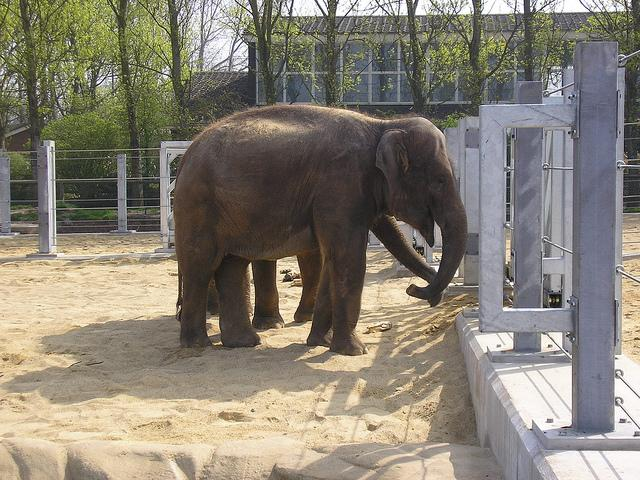What are the elephants standing in?

Choices:
A) sand
B) mud
C) woodchips
D) grass sand 